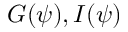<formula> <loc_0><loc_0><loc_500><loc_500>G ( \psi ) , I ( \psi )</formula> 